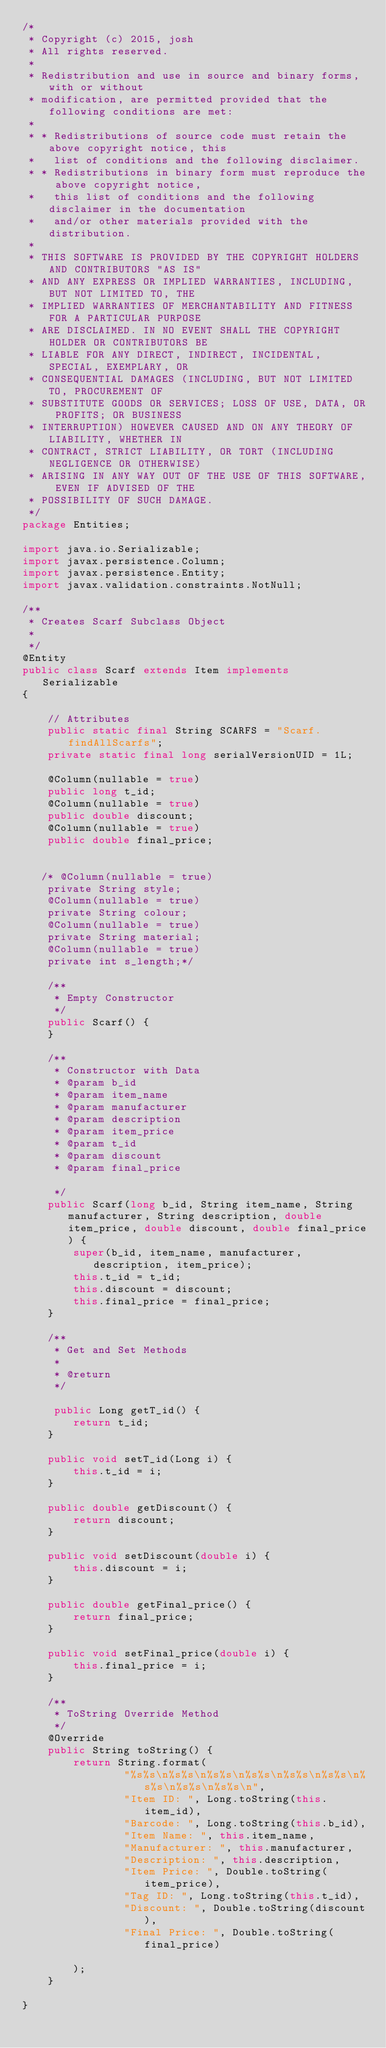Convert code to text. <code><loc_0><loc_0><loc_500><loc_500><_Java_>/*
 * Copyright (c) 2015, josh
 * All rights reserved.
 *
 * Redistribution and use in source and binary forms, with or without
 * modification, are permitted provided that the following conditions are met:
 *
 * * Redistributions of source code must retain the above copyright notice, this
 *   list of conditions and the following disclaimer.
 * * Redistributions in binary form must reproduce the above copyright notice,
 *   this list of conditions and the following disclaimer in the documentation
 *   and/or other materials provided with the distribution.
 *
 * THIS SOFTWARE IS PROVIDED BY THE COPYRIGHT HOLDERS AND CONTRIBUTORS "AS IS"
 * AND ANY EXPRESS OR IMPLIED WARRANTIES, INCLUDING, BUT NOT LIMITED TO, THE
 * IMPLIED WARRANTIES OF MERCHANTABILITY AND FITNESS FOR A PARTICULAR PURPOSE
 * ARE DISCLAIMED. IN NO EVENT SHALL THE COPYRIGHT HOLDER OR CONTRIBUTORS BE
 * LIABLE FOR ANY DIRECT, INDIRECT, INCIDENTAL, SPECIAL, EXEMPLARY, OR
 * CONSEQUENTIAL DAMAGES (INCLUDING, BUT NOT LIMITED TO, PROCUREMENT OF
 * SUBSTITUTE GOODS OR SERVICES; LOSS OF USE, DATA, OR PROFITS; OR BUSINESS
 * INTERRUPTION) HOWEVER CAUSED AND ON ANY THEORY OF LIABILITY, WHETHER IN
 * CONTRACT, STRICT LIABILITY, OR TORT (INCLUDING NEGLIGENCE OR OTHERWISE)
 * ARISING IN ANY WAY OUT OF THE USE OF THIS SOFTWARE, EVEN IF ADVISED OF THE
 * POSSIBILITY OF SUCH DAMAGE.
 */
package Entities;

import java.io.Serializable;
import javax.persistence.Column;
import javax.persistence.Entity;
import javax.validation.constraints.NotNull;

/**
 * Creates Scarf Subclass Object
 *
 */
@Entity
public class Scarf extends Item implements Serializable 
{

    // Attributes
    public static final String SCARFS = "Scarf.findAllScarfs";
    private static final long serialVersionUID = 1L;
    
    @Column(nullable = true)
    public long t_id;
    @Column(nullable = true)
    public double discount;
    @Column(nullable = true)
    public double final_price;
    
    
   /* @Column(nullable = true)
    private String style;
    @Column(nullable = true)
    private String colour;
    @Column(nullable = true)
    private String material;
    @Column(nullable = true)
    private int s_length;*/

    /**
     * Empty Constructor
     */
    public Scarf() {
    }

    /**
     * Constructor with Data
     * @param b_id
     * @param item_name
     * @param manufacturer
     * @param description
     * @param item_price
     * @param t_id
     * @param discount
     * @param final_price

     */
    public Scarf(long b_id, String item_name, String manufacturer, String description, double item_price, double discount, double final_price) {
        super(b_id, item_name, manufacturer, description, item_price);
        this.t_id = t_id;
        this.discount = discount;
        this.final_price = final_price;
    }

    /**
     * Get and Set Methods
     *
     * @return
     */
    
     public Long getT_id() {
        return t_id;
    }

    public void setT_id(Long i) {
        this.t_id = i;
    }
    
    public double getDiscount() {
        return discount;
    }

    public void setDiscount(double i) {
        this.discount = i;
    }
    
    public double getFinal_price() {
        return final_price;
    }

    public void setFinal_price(double i) {
        this.final_price = i;
    }

    /**
     * ToString Override Method
     */
    @Override
    public String toString() {
        return String.format(
                "%s%s\n%s%s\n%s%s\n%s%s\n%s%s\n%s%s\n%s%s\n%s%s\n%s%s\n",
                "Item ID: ", Long.toString(this.item_id),
                "Barcode: ", Long.toString(this.b_id),
                "Item Name: ", this.item_name,
                "Manufacturer: ", this.manufacturer,
                "Description: ", this.description,
                "Item Price: ", Double.toString(item_price),
                "Tag ID: ", Long.toString(this.t_id),
                "Discount: ", Double.toString(discount),
                "Final Price: ", Double.toString(final_price)
                
        );
    }

}</code> 